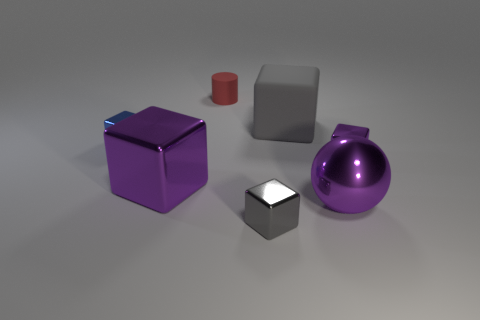Is there any other thing that is made of the same material as the ball?
Give a very brief answer. Yes. What number of cubes are gray shiny things or blue metallic objects?
Your answer should be compact. 2. There is a gray thing that is in front of the blue object; is it the same size as the blue shiny cube left of the large purple metal sphere?
Keep it short and to the point. Yes. What material is the large block on the left side of the big thing behind the small blue metal cube?
Provide a succinct answer. Metal. Are there fewer small things right of the gray rubber object than big metal spheres?
Provide a succinct answer. No. There is another thing that is the same material as the big gray thing; what is its shape?
Keep it short and to the point. Cylinder. What number of other things are there of the same shape as the tiny blue object?
Ensure brevity in your answer.  4. What number of blue objects are either big rubber things or large metal spheres?
Provide a succinct answer. 0. Do the tiny blue thing and the small red rubber object have the same shape?
Provide a short and direct response. No. There is a large purple metal thing right of the small red matte thing; is there a small purple thing on the right side of it?
Offer a very short reply. Yes. 